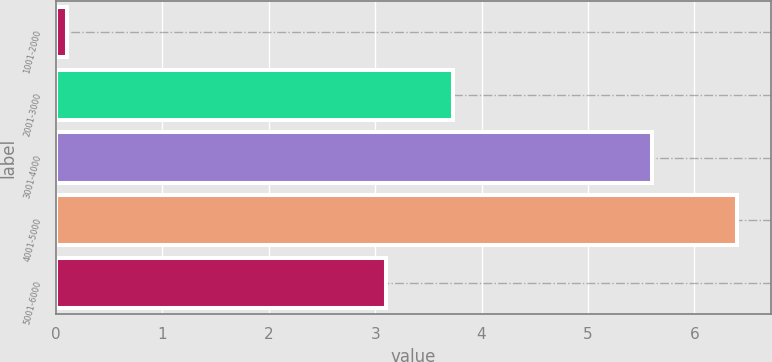Convert chart. <chart><loc_0><loc_0><loc_500><loc_500><bar_chart><fcel>1001-2000<fcel>2001-3000<fcel>3001-4000<fcel>4001-5000<fcel>5001-6000<nl><fcel>0.1<fcel>3.73<fcel>5.6<fcel>6.4<fcel>3.1<nl></chart> 